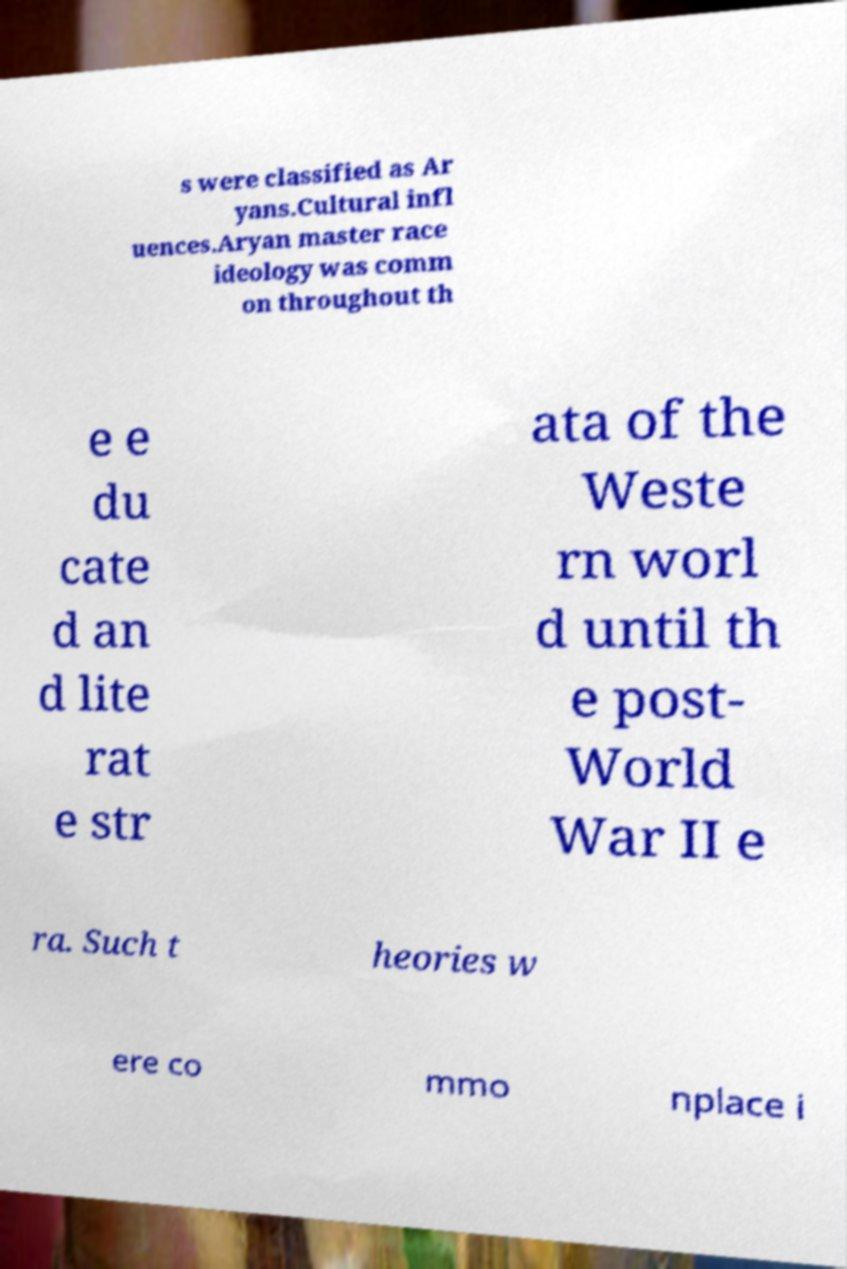Please identify and transcribe the text found in this image. s were classified as Ar yans.Cultural infl uences.Aryan master race ideology was comm on throughout th e e du cate d an d lite rat e str ata of the Weste rn worl d until th e post- World War II e ra. Such t heories w ere co mmo nplace i 